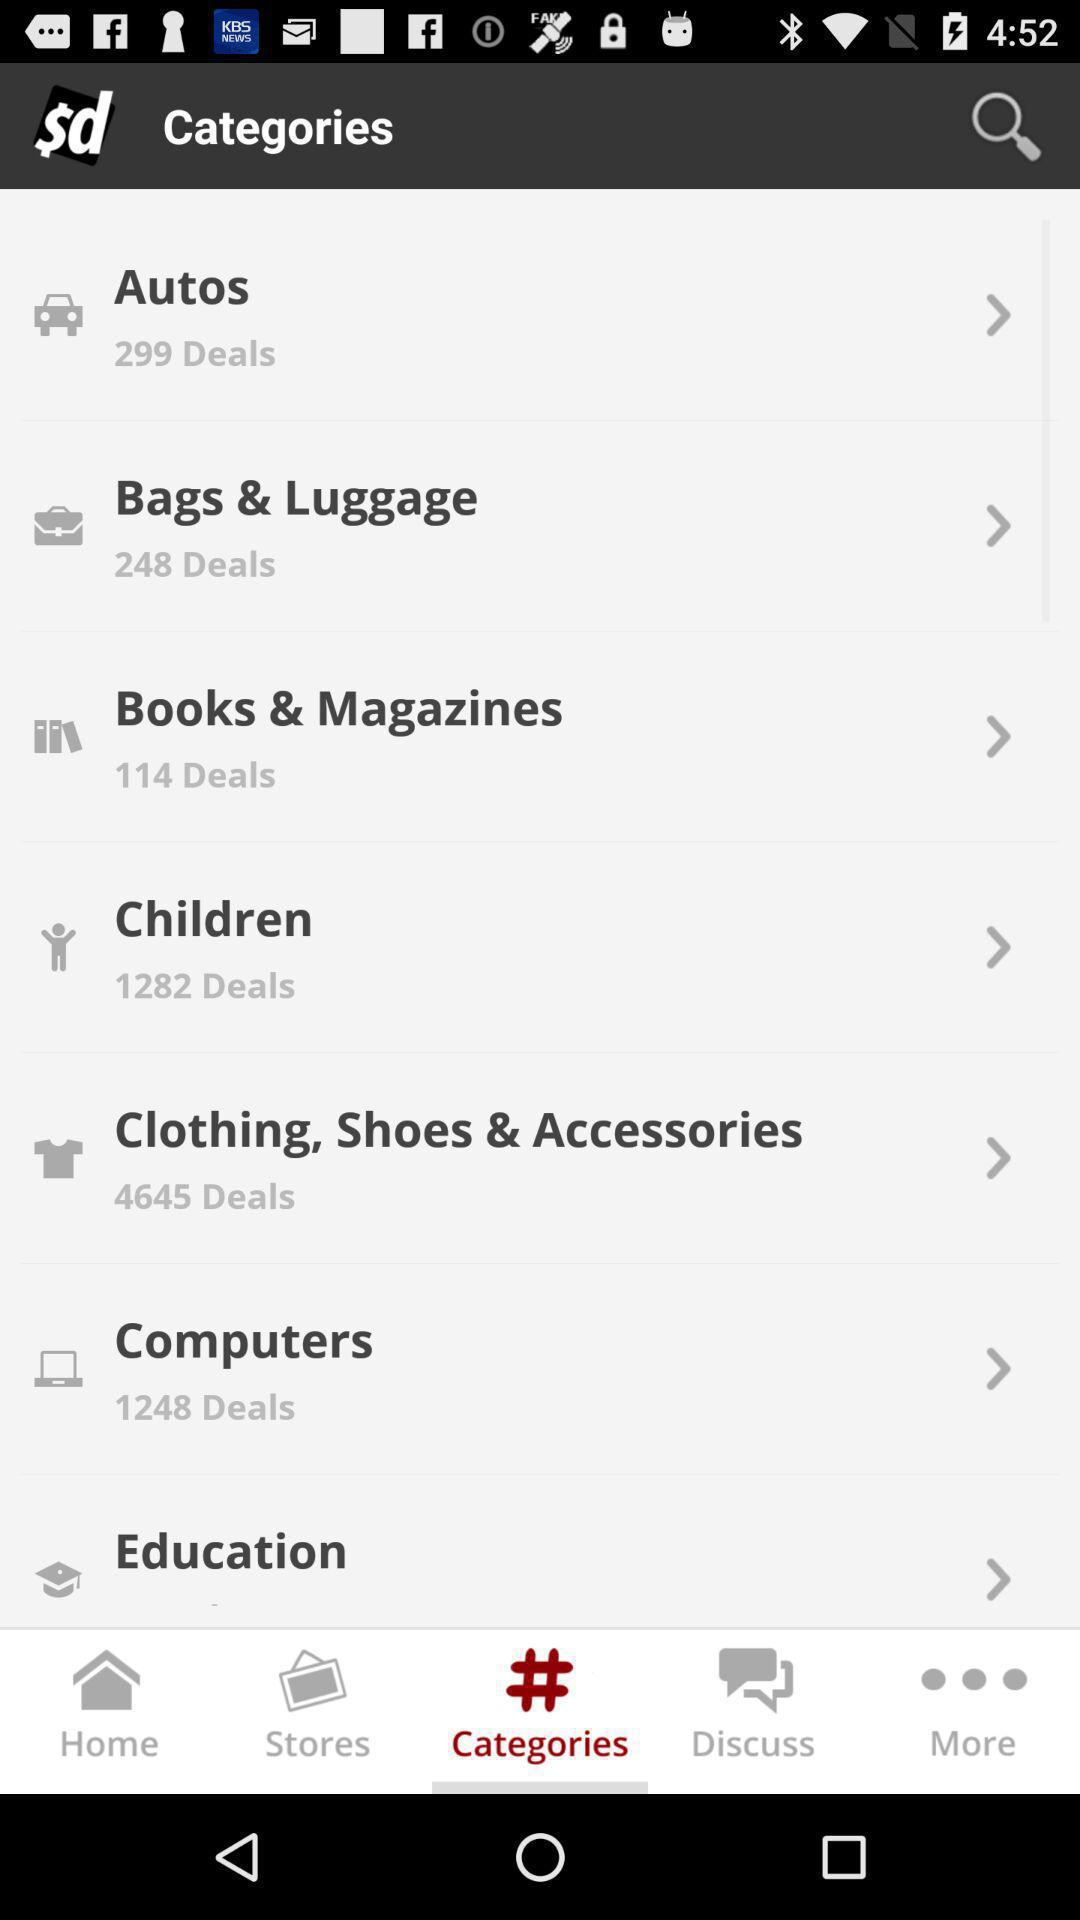How many deals are there in "Autos"? There are 299 deals. 